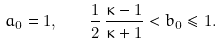<formula> <loc_0><loc_0><loc_500><loc_500>a _ { 0 } = 1 , \quad \frac { 1 } { 2 } \, \frac { \kappa - 1 } { \kappa + 1 } < b _ { 0 } \leq 1 .</formula> 